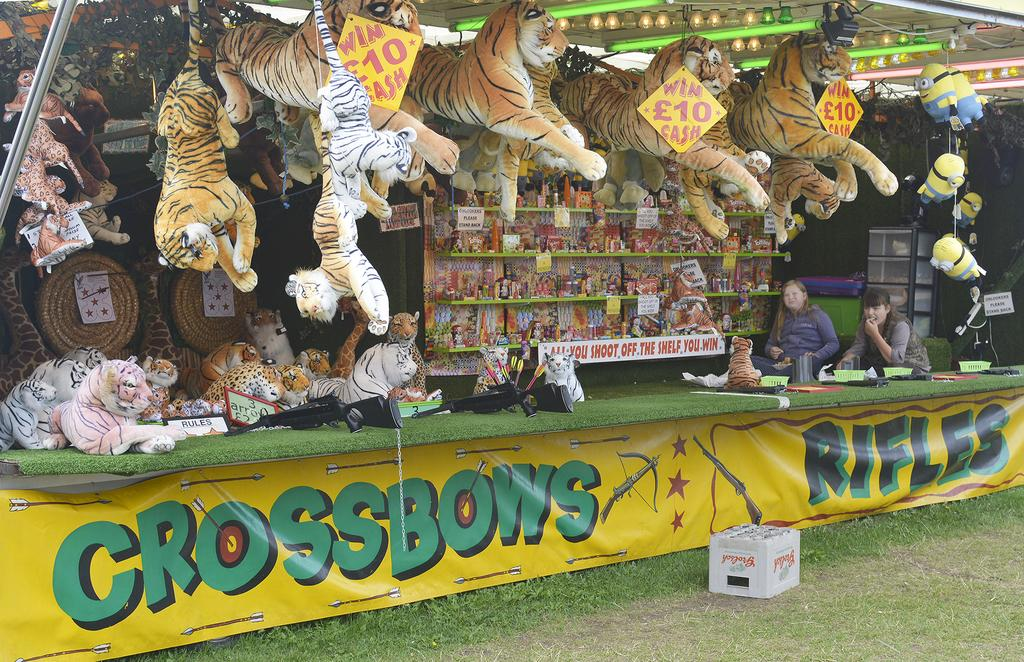What type of structure is present in the image? There is a stall in the image. What can be seen on the stall? The stall has a banner, a tray, baskets, arrows, toys on shelves, and boards. How many persons are in the image? There are two persons in the image. What type of lighting is present in the image? There are lights in the image. What type of floor can be seen in the image? There is no floor visible in the image, as it is focused on the stall and its contents. What type of spoon is used to serve the toys in the image? There are no spoons present in the image, as the toys are displayed on shelves. 